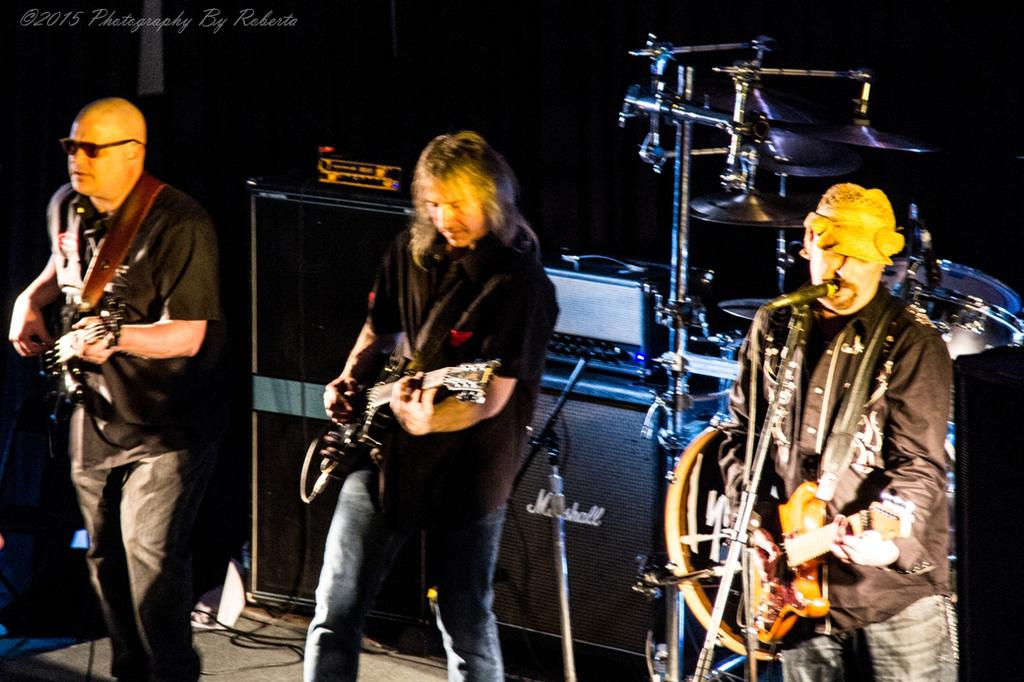How many people are in the image? There are three persons standing in the image. What are the three persons doing? The three persons are playing guitar. Is there anyone else performing in the image? Yes, there is a person singing on a mic. What can be seen in the background of the image? There are speakers visible in the background. How would you describe the lighting in the image? The setting is dark. Can you see a rake being used by any of the musicians in the image? No, there is no rake present in the image. Is there a lawyer playing the guitar in the image? There is no mention of a lawyer or any profession in the image; the focus is on the musical activities. Is there a yak in the image? No, there is no yak present in the image. 